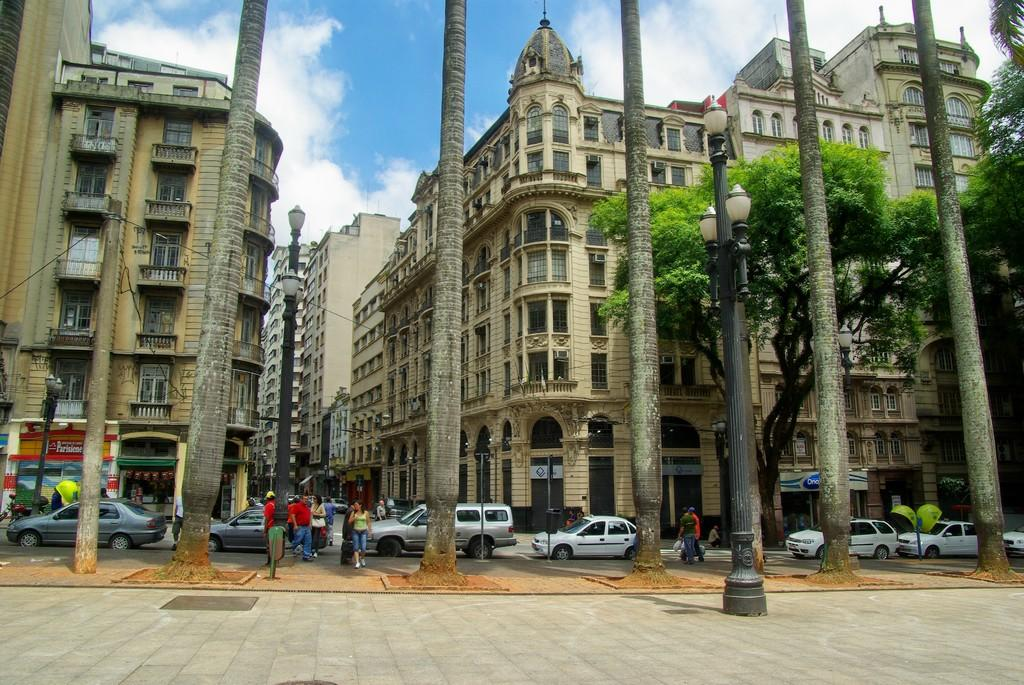What type of structures can be seen in the image? There are buildings in the image. What type of lighting is present in the image? There are street lamps in the image. What type of vegetation is present in the image? There are trees in the image. What part of the natural environment is visible in the image? The sky is visible in the image, and there are clouds in the sky. What type of vehicles are present in the image? There are cars in the image. What type of traffic control device is present in the image? There is a traffic signal in the image. What type of activity can be seen in the image? There are people walking in the image. What type of channel can be seen running through the image? There is no channel present in the image. What type of tree is growing in the middle of the street in the image? There are no trees growing in the middle of the street in the image. What type of eggnog is being served at the cafe in the image? There is no cafe or eggnog present in the image. 